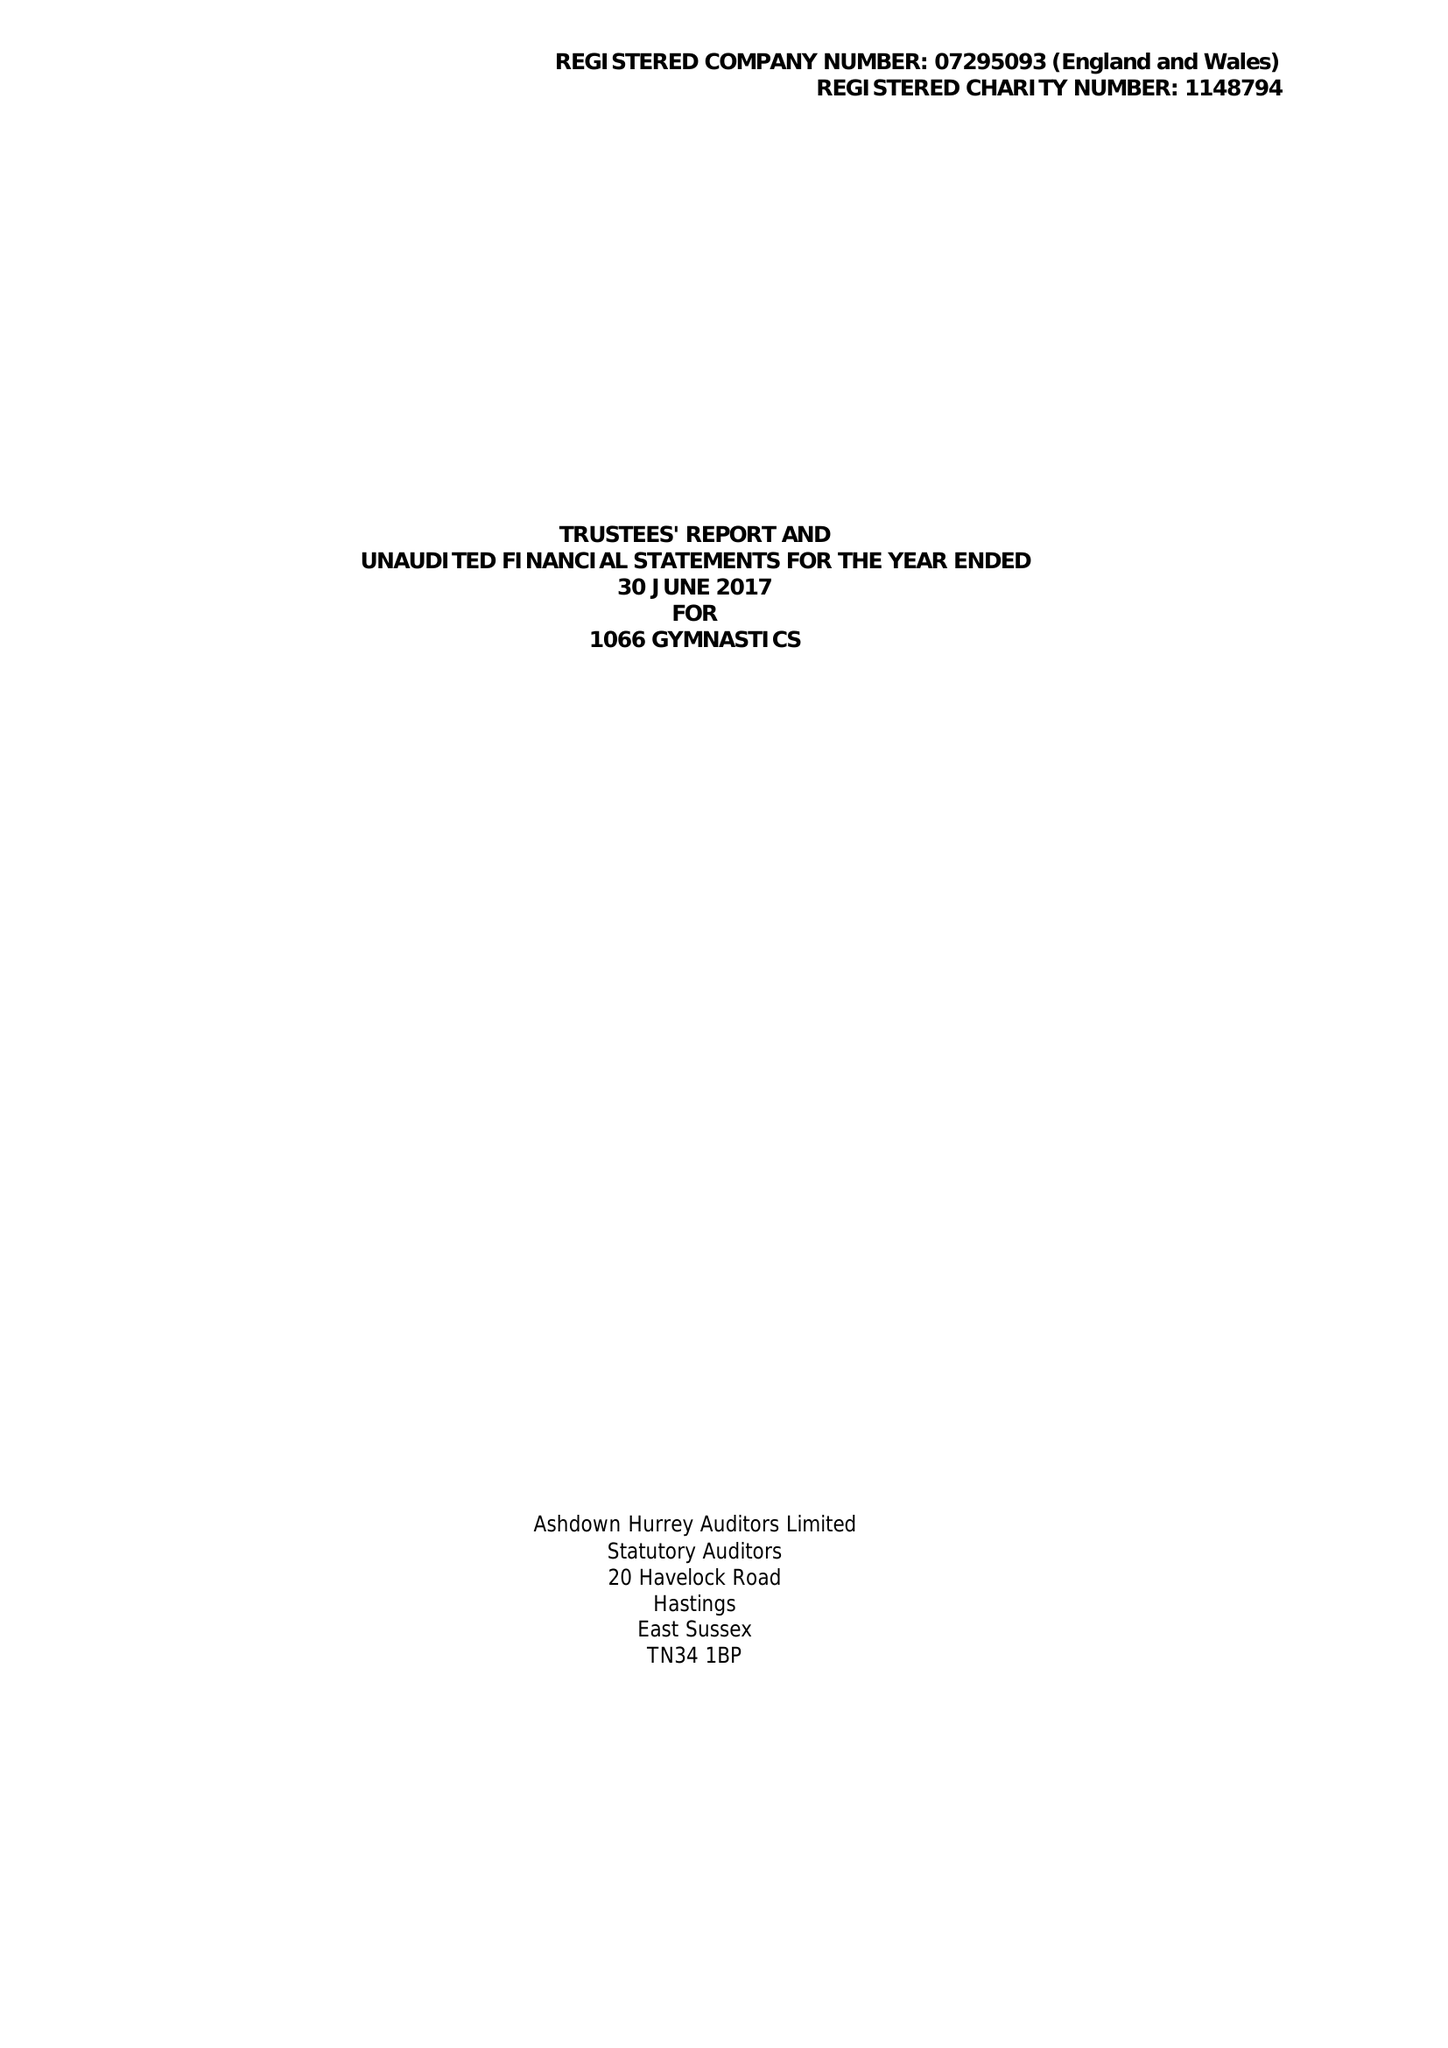What is the value for the report_date?
Answer the question using a single word or phrase. 2017-06-30 